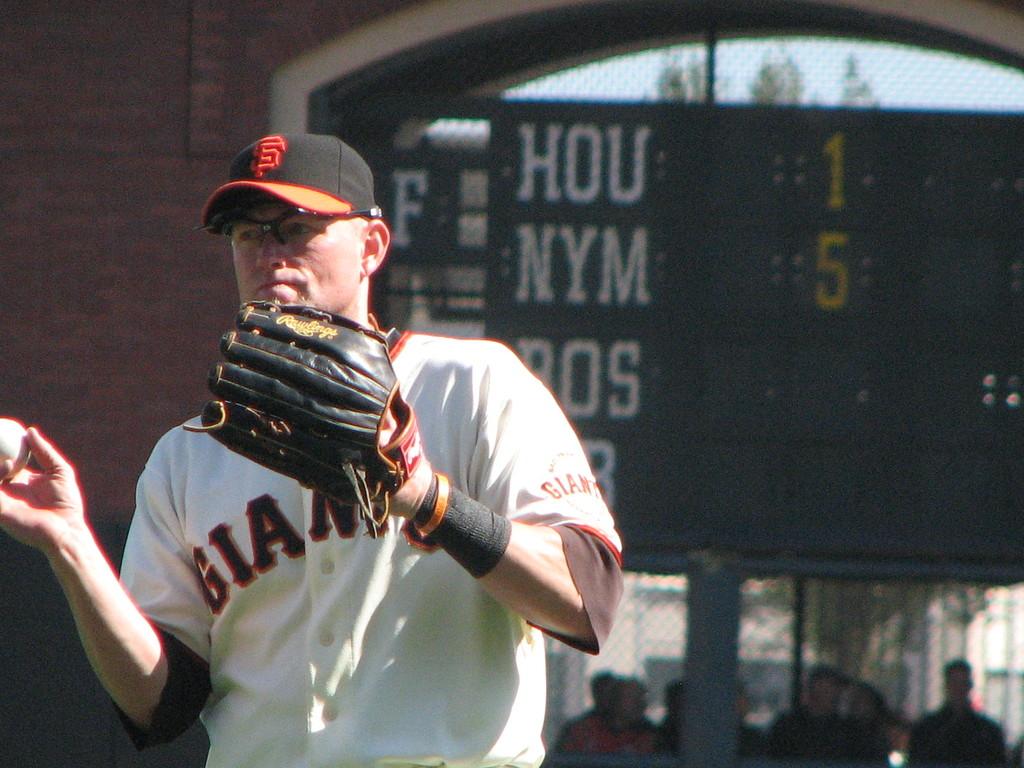How many runs do the nym have?
Provide a succinct answer. 5. How many runs does hou have?
Your response must be concise. 1. 